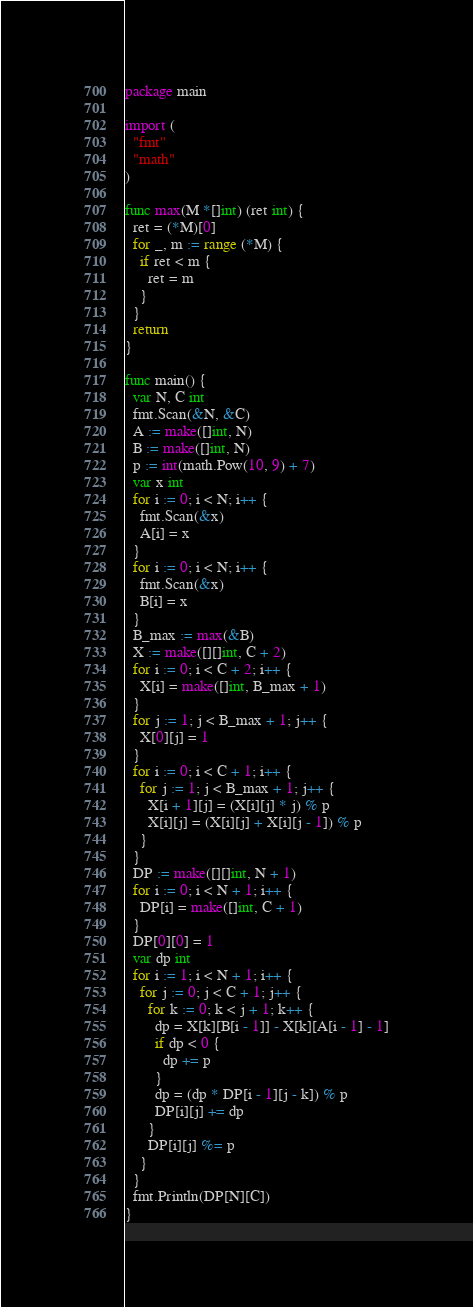<code> <loc_0><loc_0><loc_500><loc_500><_Go_>package main
 
import (
  "fmt"
  "math"
)
 
func max(M *[]int) (ret int) {
  ret = (*M)[0]
  for _, m := range (*M) {
    if ret < m {
      ret = m
    }
  }
  return
}
 
func main() {
  var N, C int
  fmt.Scan(&N, &C)
  A := make([]int, N)
  B := make([]int, N)
  p := int(math.Pow(10, 9) + 7)
  var x int
  for i := 0; i < N; i++ {
    fmt.Scan(&x)
    A[i] = x
  }
  for i := 0; i < N; i++ {
    fmt.Scan(&x)
    B[i] = x
  }
  B_max := max(&B)
  X := make([][]int, C + 2)
  for i := 0; i < C + 2; i++ {
    X[i] = make([]int, B_max + 1)
  }
  for j := 1; j < B_max + 1; j++ {
    X[0][j] = 1
  }
  for i := 0; i < C + 1; i++ {
    for j := 1; j < B_max + 1; j++ {
      X[i + 1][j] = (X[i][j] * j) % p
      X[i][j] = (X[i][j] + X[i][j - 1]) % p
    }
  }
  DP := make([][]int, N + 1)
  for i := 0; i < N + 1; i++ {
    DP[i] = make([]int, C + 1)
  }
  DP[0][0] = 1
  var dp int
  for i := 1; i < N + 1; i++ {
    for j := 0; j < C + 1; j++ {
      for k := 0; k < j + 1; k++ {
        dp = X[k][B[i - 1]] - X[k][A[i - 1] - 1]
        if dp < 0 {
          dp += p
        }
        dp = (dp * DP[i - 1][j - k]) % p
        DP[i][j] += dp
      }
      DP[i][j] %= p
    }
  }
  fmt.Println(DP[N][C])
}</code> 